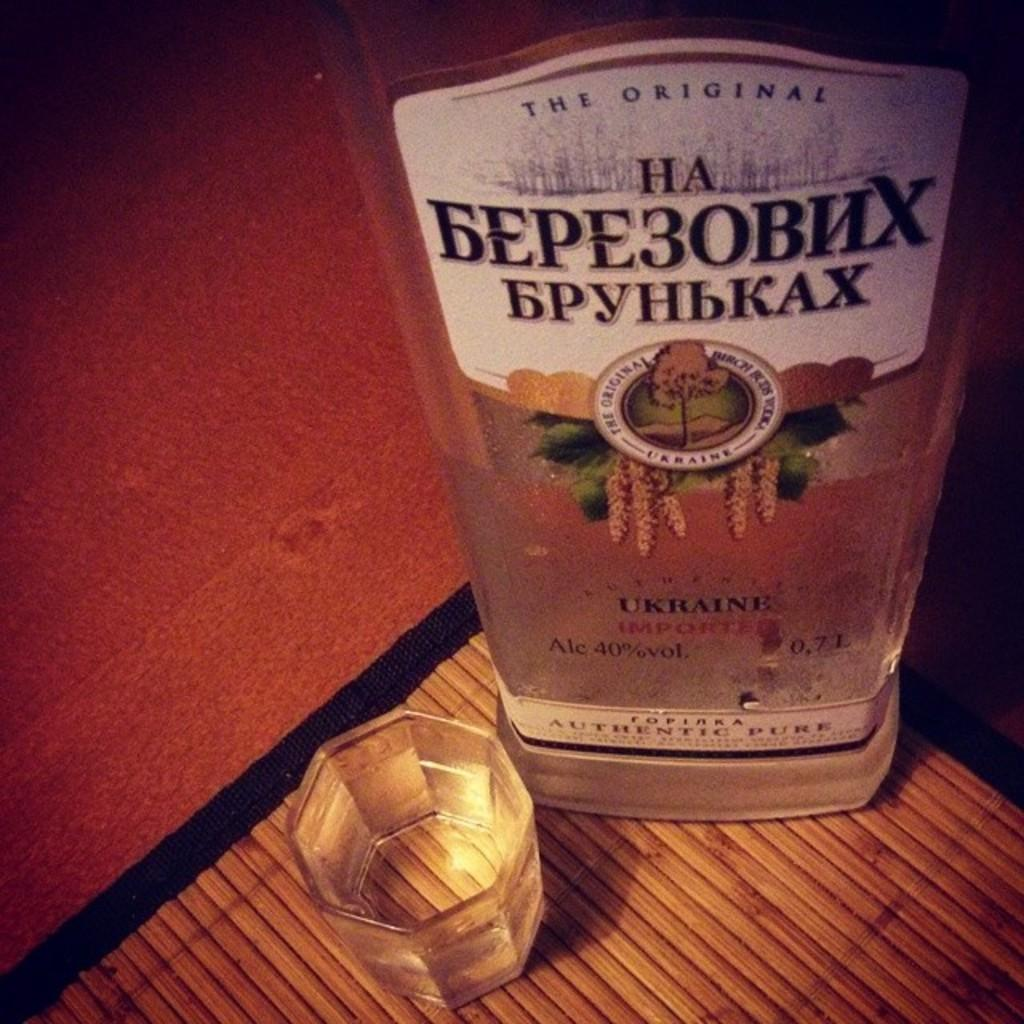<image>
Render a clear and concise summary of the photo. A bottle of alcohol from the Ukraine is next to a shot glass. 